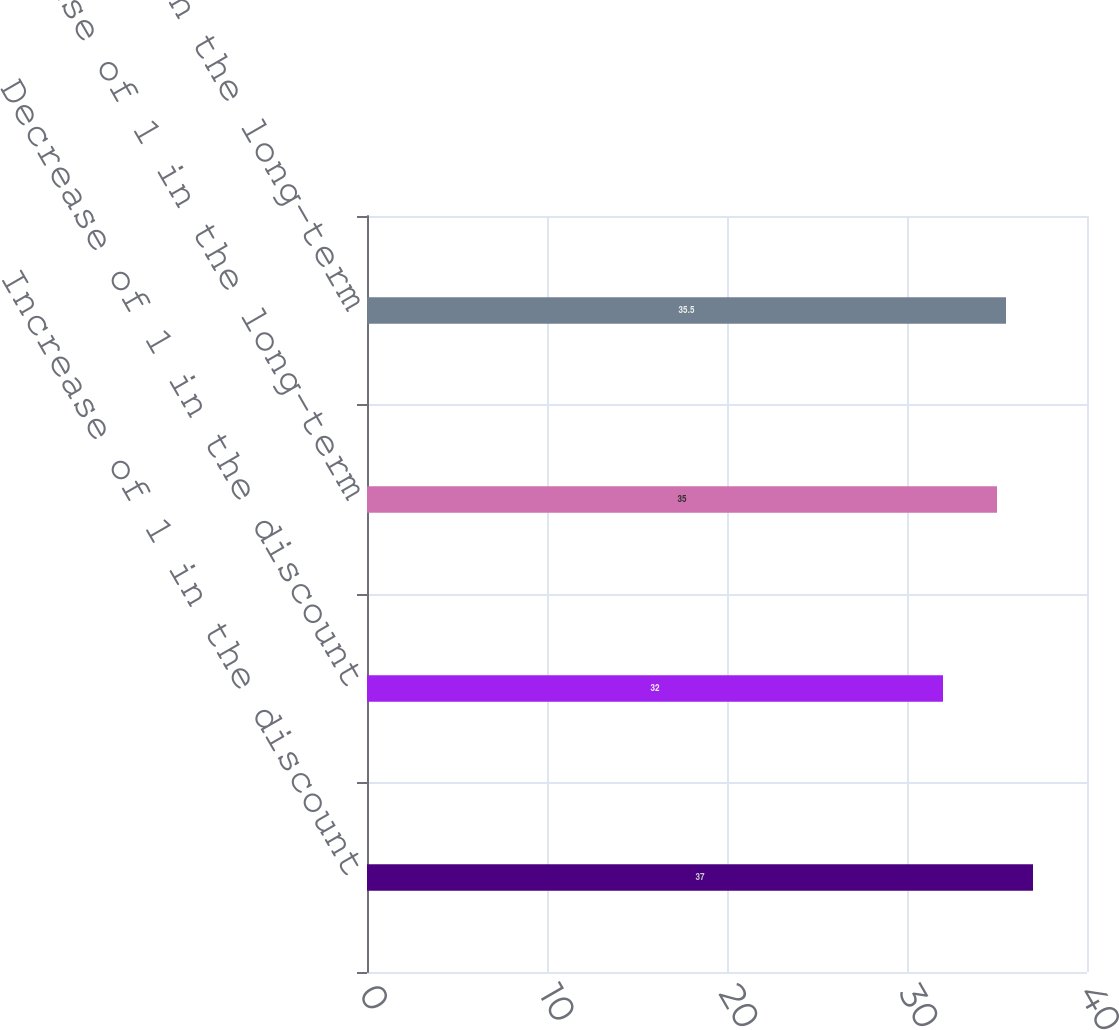Convert chart. <chart><loc_0><loc_0><loc_500><loc_500><bar_chart><fcel>Increase of 1 in the discount<fcel>Decrease of 1 in the discount<fcel>Increase of 1 in the long-term<fcel>Decrease of 1 in the long-term<nl><fcel>37<fcel>32<fcel>35<fcel>35.5<nl></chart> 